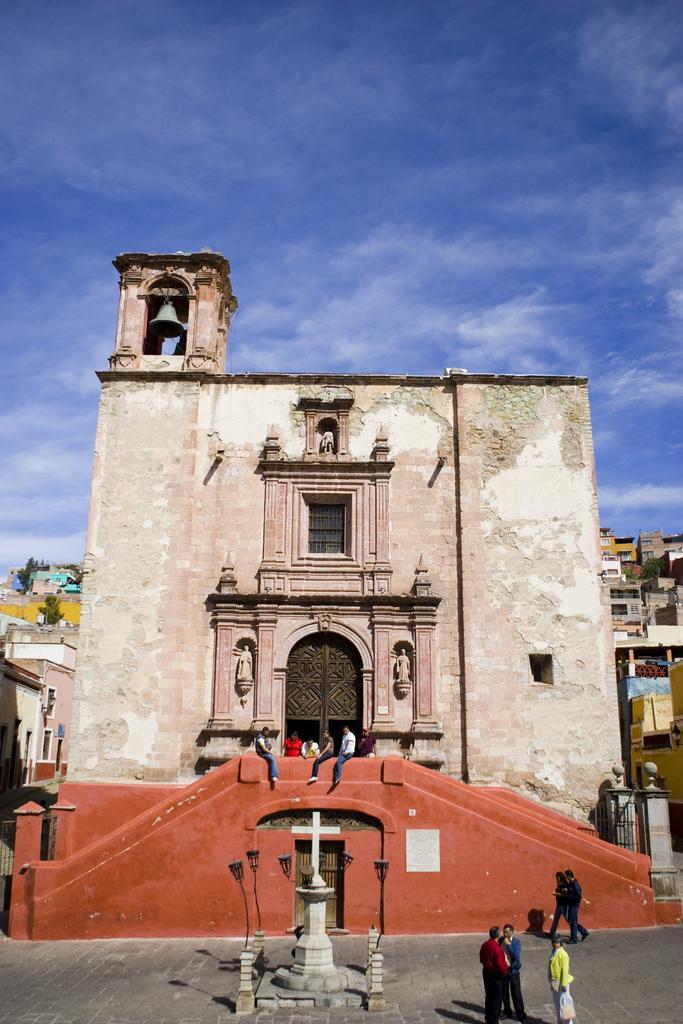In one or two sentences, can you explain what this image depicts? In this picture we can see people and in the background we can see buildings, trees and the sky. 